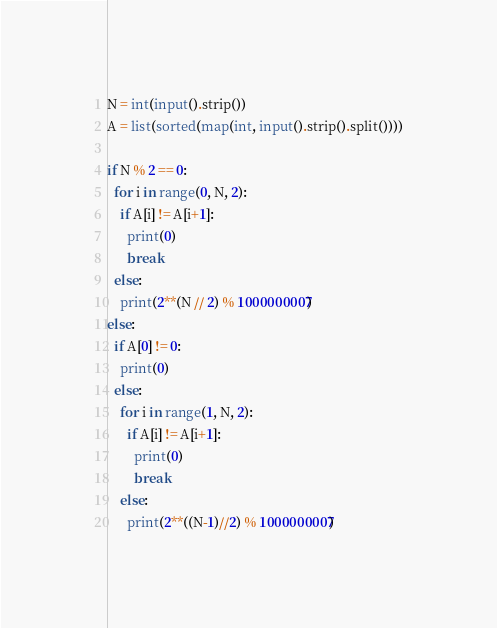<code> <loc_0><loc_0><loc_500><loc_500><_Python_>N = int(input().strip())
A = list(sorted(map(int, input().strip().split())))

if N % 2 == 0:
  for i in range(0, N, 2):
    if A[i] != A[i+1]:
      print(0)
      break
  else:
    print(2**(N // 2) % 1000000007)
else:
  if A[0] != 0:
    print(0)
  else:
    for i in range(1, N, 2):
      if A[i] != A[i+1]:
        print(0)
        break
    else:
      print(2**((N-1)//2) % 1000000007)</code> 